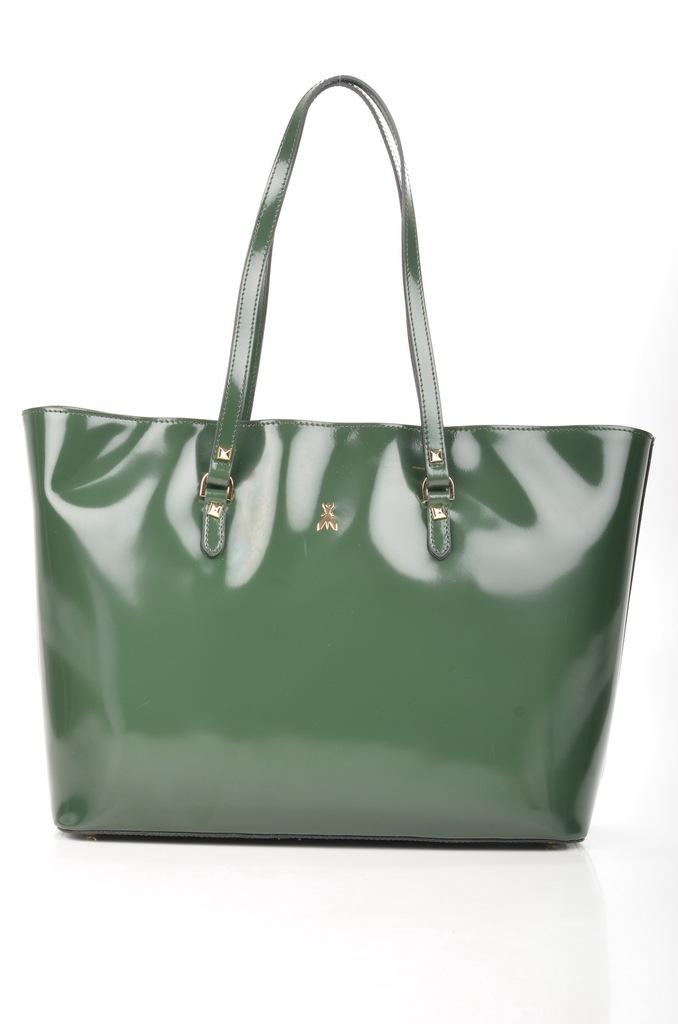What type of bag is in the image? The bag is a ladies bag. What color is the bag? The bag is green in color. Where is the bag placed in the image? The bag is kept on a white color floor. What is the color of the background in the image? The background of the image is white. What type of flame can be seen coming from the bag in the image? There is no flame present in the image; it is a bag kept on a white color floor. 